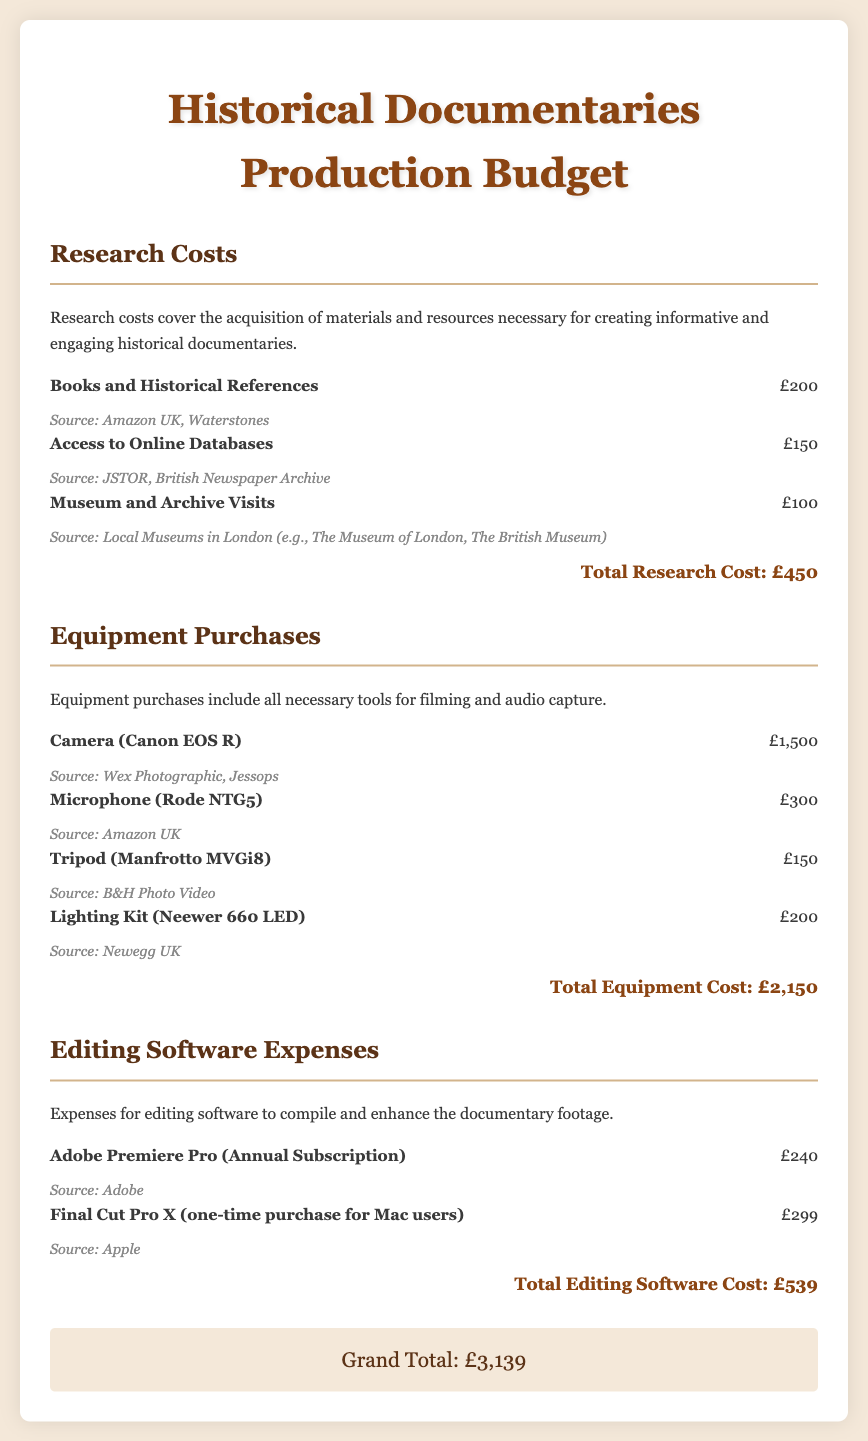What is the total budget for research costs? The total budget for research costs is stated at the end of the research costs section.
Answer: £450 What is the cost of the Camera (Canon EOS R)? The cost of the camera can be found in the equipment purchases section among the listed items.
Answer: £1,500 What is the total amount spent on editing software? The total amount spent on editing software is provided at the end of the editing software expenses section.
Answer: £539 Which microphone is included in the equipment purchases? The name of the microphone is listed under equipment purchases, providing specific details about the items.
Answer: Rode NTG5 What is the grand total for all expenses? The grand total is mentioned at the end of the budget document, summing up all the previous sections.
Answer: £3,139 How much was spent on museum and archive visits? The expenditure for museum and archive visits can be directly found in the research costs section.
Answer: £100 What type of software is Adobe Premiere Pro? This software type is specified in the editing software expenses section, which includes details about software costs.
Answer: Editing software What is the total cost of equipment purchases? The total cost for equipment purchases is stated at the end of the equipment purchases section, combining all listed items.
Answer: £2,150 How many items are listed under research costs? The document lists several specific items under research costs, which can be counted in the respective section.
Answer: 3 